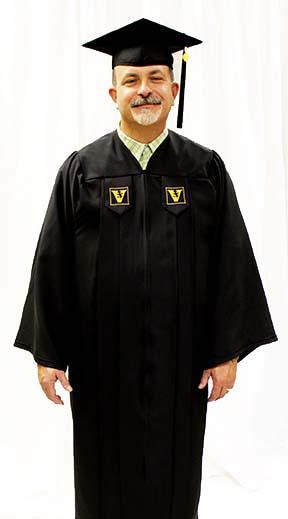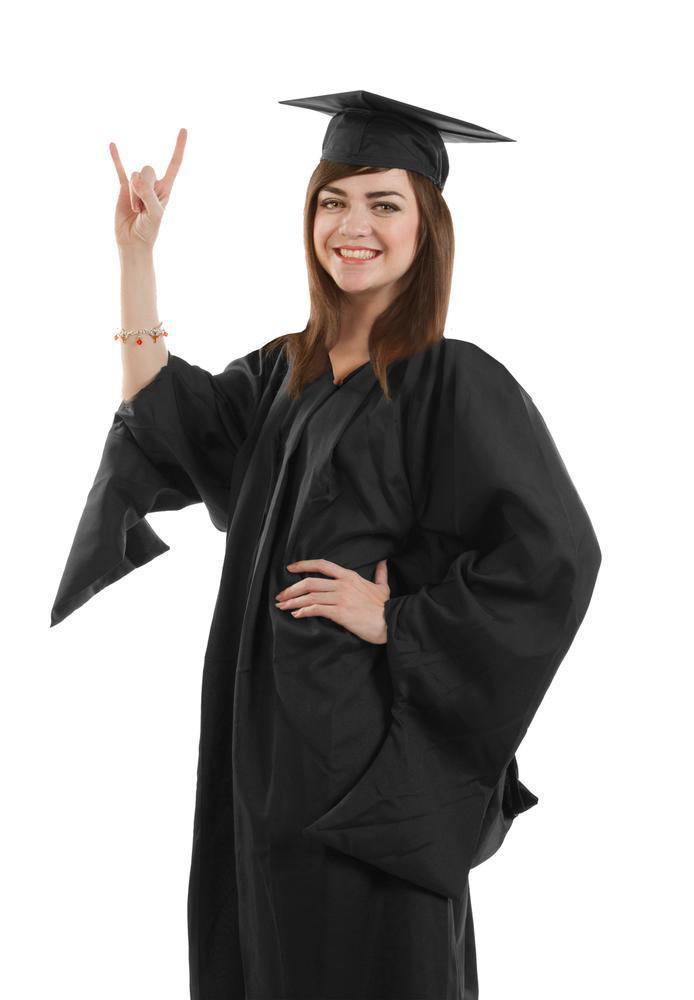The first image is the image on the left, the second image is the image on the right. Given the left and right images, does the statement "White sleeves are almost completely exposed in one of the images." hold true? Answer yes or no. No. 